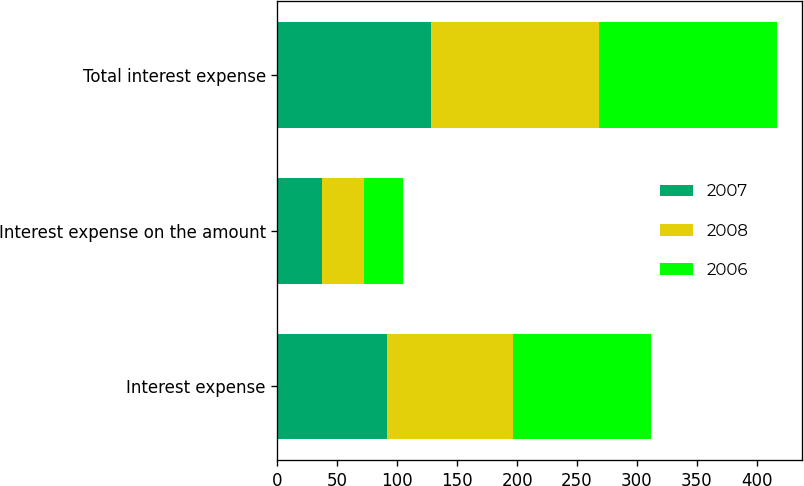<chart> <loc_0><loc_0><loc_500><loc_500><stacked_bar_chart><ecel><fcel>Interest expense<fcel>Interest expense on the amount<fcel>Total interest expense<nl><fcel>2007<fcel>91.2<fcel>36.9<fcel>128.1<nl><fcel>2008<fcel>105.6<fcel>35<fcel>140.6<nl><fcel>2006<fcel>114.8<fcel>33.2<fcel>148<nl></chart> 